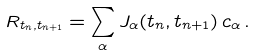<formula> <loc_0><loc_0><loc_500><loc_500>R _ { t _ { n } , t _ { n + 1 } } = \sum _ { \alpha } J _ { \alpha } ( t _ { n } , t _ { n + 1 } ) \, c _ { \alpha } \, .</formula> 